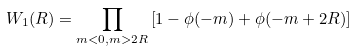<formula> <loc_0><loc_0><loc_500><loc_500>W _ { 1 } ( R ) = \prod _ { m < 0 , m > 2 R } \left [ 1 - \phi ( - m ) + \phi ( - m + 2 R ) \right ]</formula> 